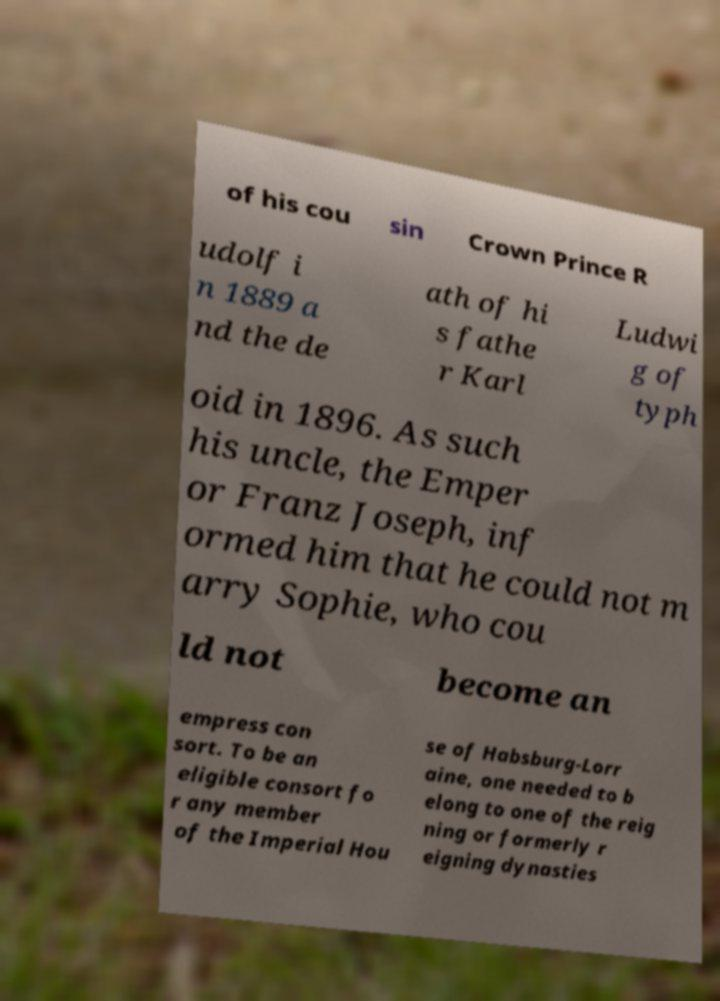Can you accurately transcribe the text from the provided image for me? of his cou sin Crown Prince R udolf i n 1889 a nd the de ath of hi s fathe r Karl Ludwi g of typh oid in 1896. As such his uncle, the Emper or Franz Joseph, inf ormed him that he could not m arry Sophie, who cou ld not become an empress con sort. To be an eligible consort fo r any member of the Imperial Hou se of Habsburg-Lorr aine, one needed to b elong to one of the reig ning or formerly r eigning dynasties 